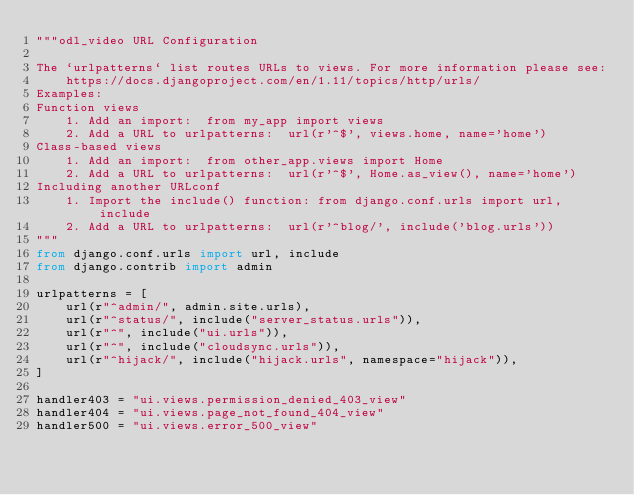Convert code to text. <code><loc_0><loc_0><loc_500><loc_500><_Python_>"""odl_video URL Configuration

The `urlpatterns` list routes URLs to views. For more information please see:
    https://docs.djangoproject.com/en/1.11/topics/http/urls/
Examples:
Function views
    1. Add an import:  from my_app import views
    2. Add a URL to urlpatterns:  url(r'^$', views.home, name='home')
Class-based views
    1. Add an import:  from other_app.views import Home
    2. Add a URL to urlpatterns:  url(r'^$', Home.as_view(), name='home')
Including another URLconf
    1. Import the include() function: from django.conf.urls import url, include
    2. Add a URL to urlpatterns:  url(r'^blog/', include('blog.urls'))
"""
from django.conf.urls import url, include
from django.contrib import admin

urlpatterns = [
    url(r"^admin/", admin.site.urls),
    url(r"^status/", include("server_status.urls")),
    url(r"^", include("ui.urls")),
    url(r"^", include("cloudsync.urls")),
    url(r"^hijack/", include("hijack.urls", namespace="hijack")),
]

handler403 = "ui.views.permission_denied_403_view"
handler404 = "ui.views.page_not_found_404_view"
handler500 = "ui.views.error_500_view"
</code> 